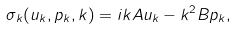Convert formula to latex. <formula><loc_0><loc_0><loc_500><loc_500>\sigma _ { k } ( u _ { k } , p _ { k } , k ) = i k A u _ { k } - k ^ { 2 } B p _ { k } ,</formula> 